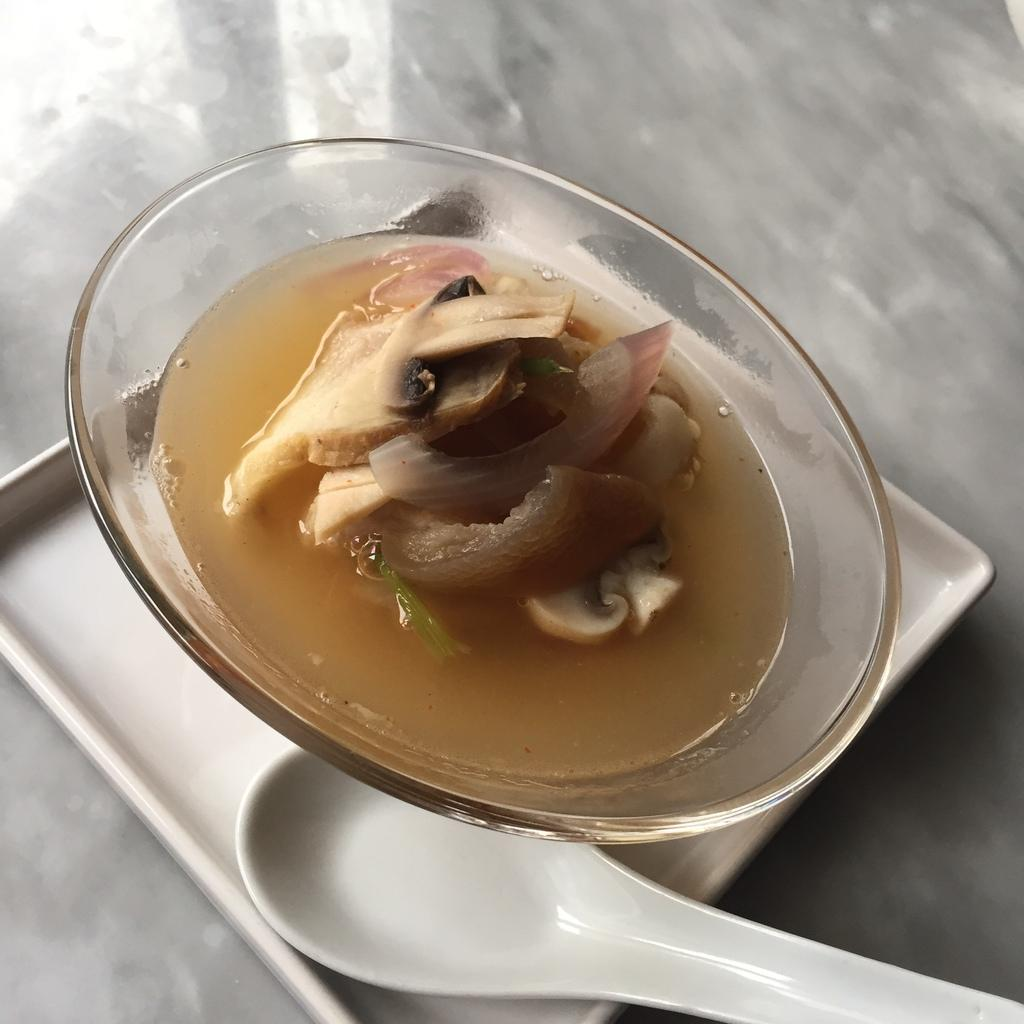What is in the bowl that is visible in the image? There is food in a bowl in the image. How is the bowl arranged in the image? The bowl is placed in a tray. What utensil is present in the image? A spoon is present in the image. On what surface are the food, bowl, tray, and spoon kept? The food, bowl, tray, and spoon are kept on a surface. What type of toothpaste is being used to prepare the food in the image? There is no toothpaste present in the image, and it is not used for preparing food. 